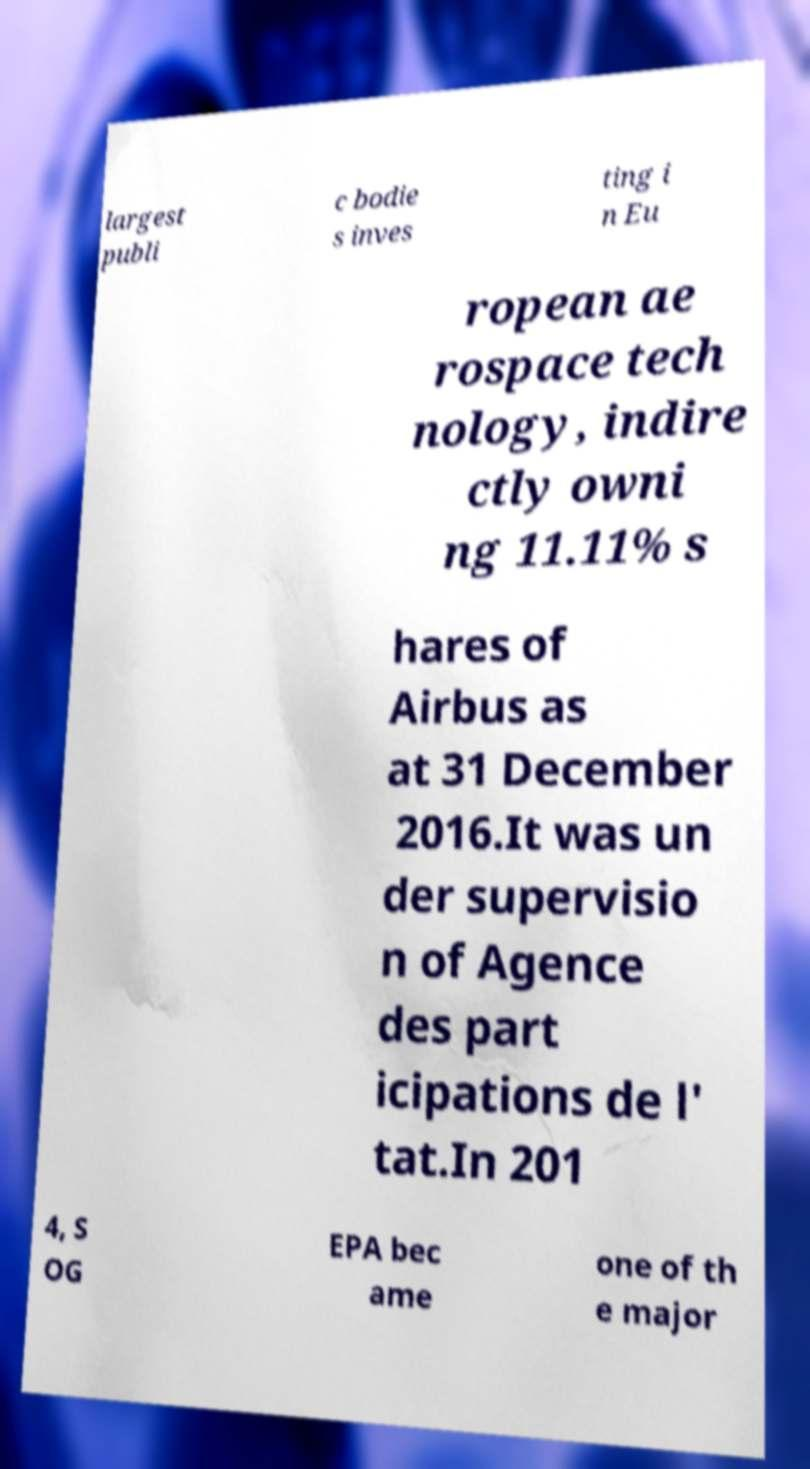Please identify and transcribe the text found in this image. largest publi c bodie s inves ting i n Eu ropean ae rospace tech nology, indire ctly owni ng 11.11% s hares of Airbus as at 31 December 2016.It was un der supervisio n of Agence des part icipations de l' tat.In 201 4, S OG EPA bec ame one of th e major 